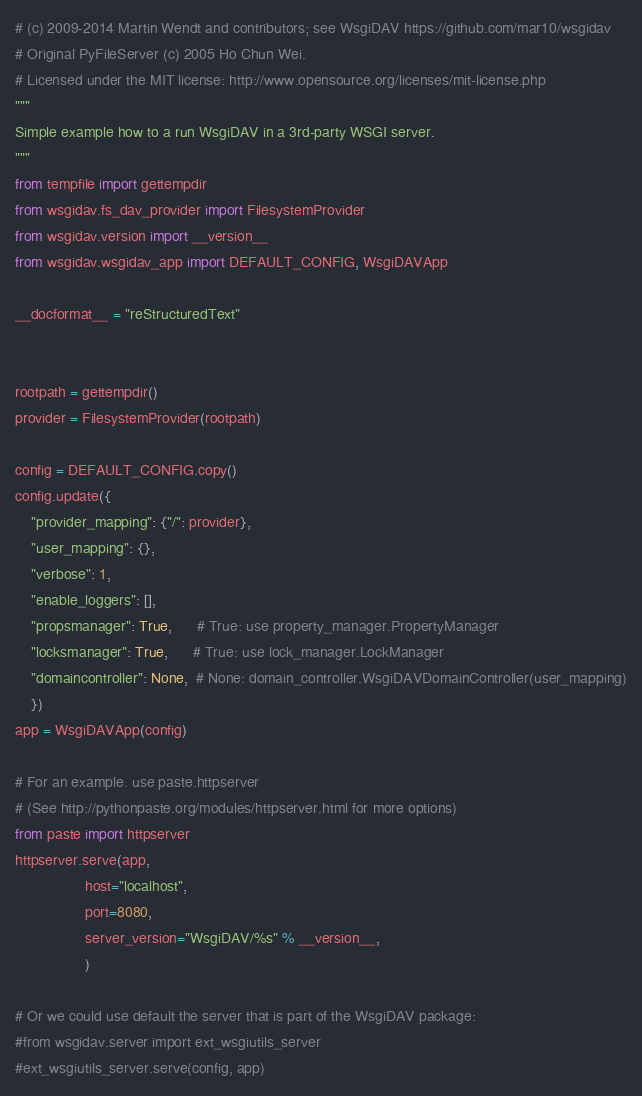<code> <loc_0><loc_0><loc_500><loc_500><_Python_># (c) 2009-2014 Martin Wendt and contributors; see WsgiDAV https://github.com/mar10/wsgidav
# Original PyFileServer (c) 2005 Ho Chun Wei.
# Licensed under the MIT license: http://www.opensource.org/licenses/mit-license.php
"""
Simple example how to a run WsgiDAV in a 3rd-party WSGI server.
"""
from tempfile import gettempdir
from wsgidav.fs_dav_provider import FilesystemProvider
from wsgidav.version import __version__
from wsgidav.wsgidav_app import DEFAULT_CONFIG, WsgiDAVApp

__docformat__ = "reStructuredText"


rootpath = gettempdir()
provider = FilesystemProvider(rootpath)

config = DEFAULT_CONFIG.copy()
config.update({
    "provider_mapping": {"/": provider},
    "user_mapping": {},
    "verbose": 1,
    "enable_loggers": [],
    "propsmanager": True,      # True: use property_manager.PropertyManager                    
    "locksmanager": True,      # True: use lock_manager.LockManager                   
    "domaincontroller": None,  # None: domain_controller.WsgiDAVDomainController(user_mapping)
    })
app = WsgiDAVApp(config)

# For an example. use paste.httpserver
# (See http://pythonpaste.org/modules/httpserver.html for more options)
from paste import httpserver
httpserver.serve(app, 
                 host="localhost", 
                 port=8080,
                 server_version="WsgiDAV/%s" % __version__,
                 )

# Or we could use default the server that is part of the WsgiDAV package:
#from wsgidav.server import ext_wsgiutils_server
#ext_wsgiutils_server.serve(config, app)
</code> 